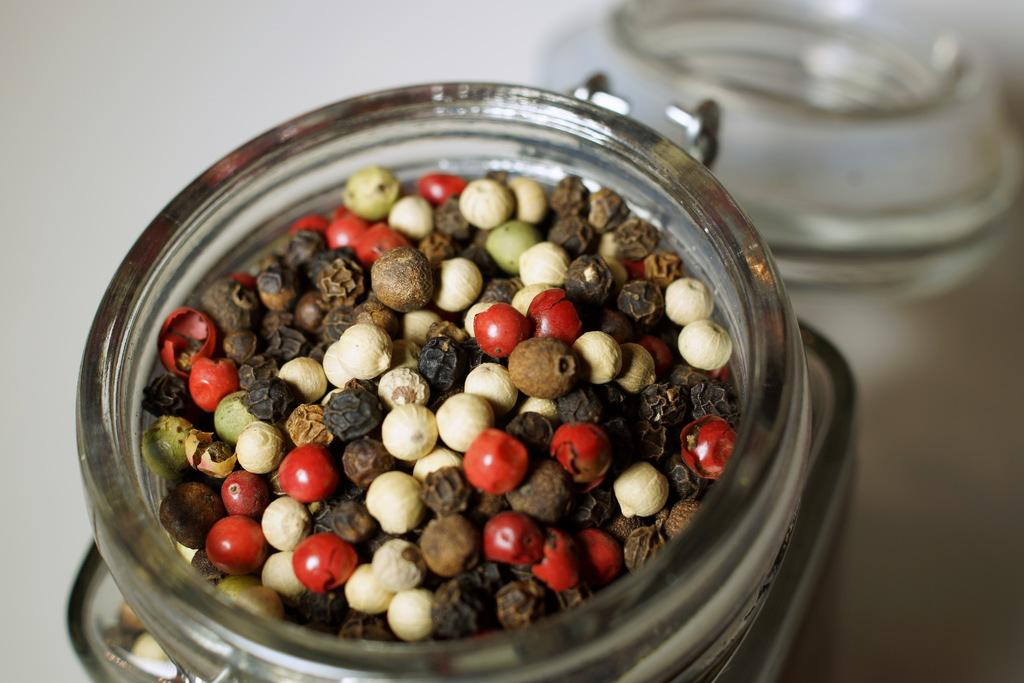What type of container is used to store the food items in the image? The food items are in a glass jar. Is the glass jar sealed in any way? Yes, there is a lid on the glass jar. What type of grain is being harvested by the company in the image? There is no company or grain present in the image; it only shows food items in a glass jar with a lid. 